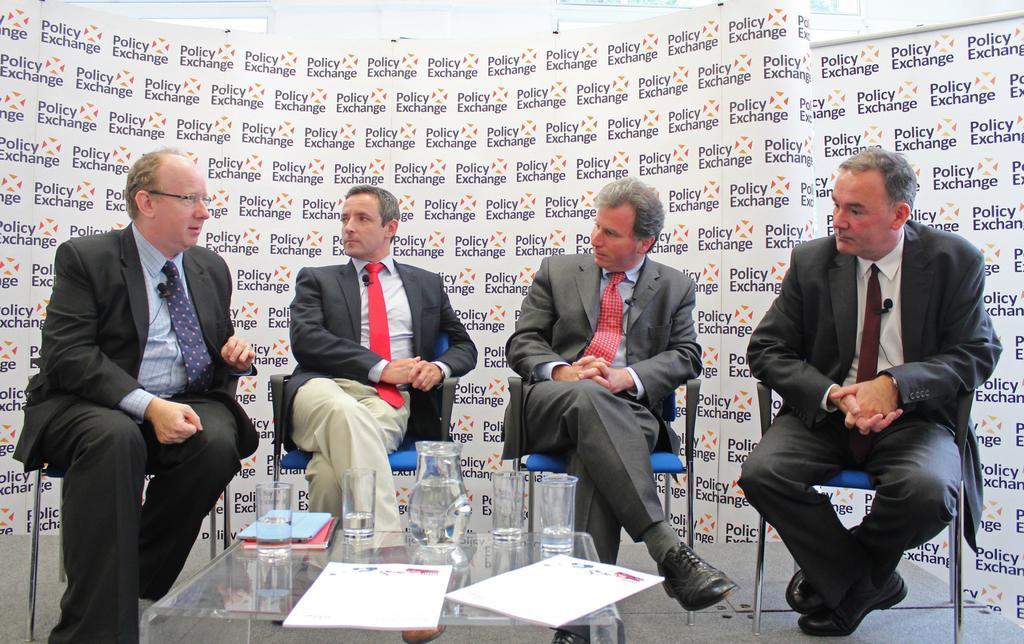In one or two sentences, can you explain what this image depicts? In the image we can see there are people who are sitting on chair and on table there is a jug, glasses. 